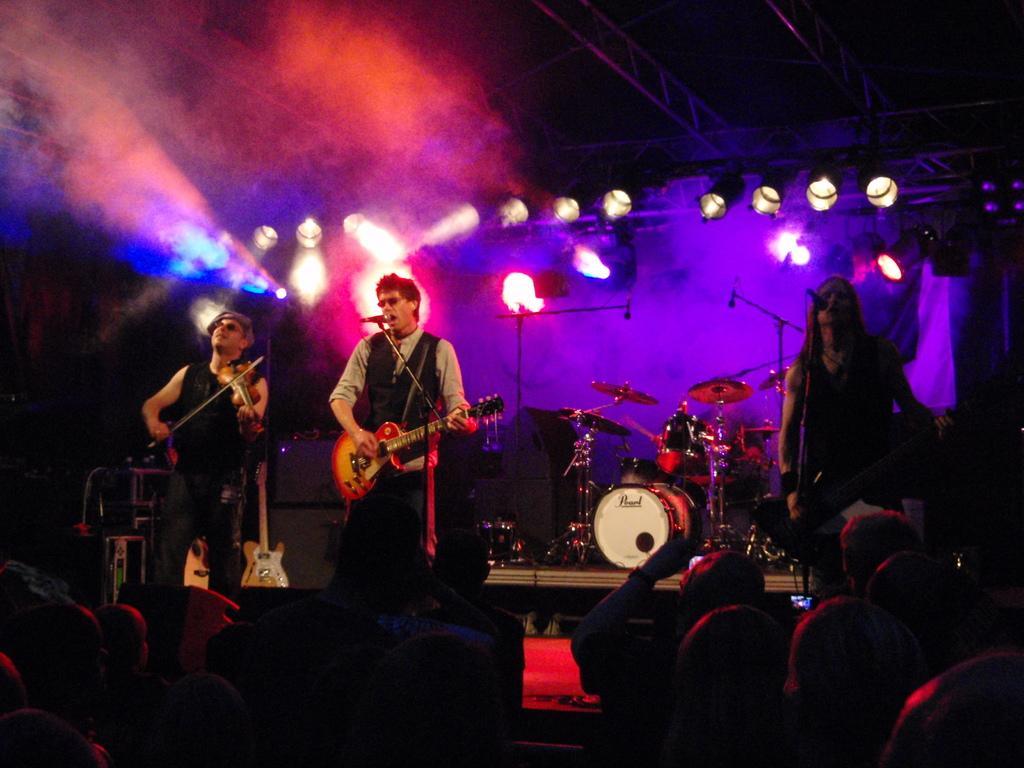Describe this image in one or two sentences. In the image there are three people who are standing and playing their musical instruments. In middle there is a man playing a guitar and opened his mouth in front of a microphone for singing and there are group of people as audience. In background we can see few musical instruments on top there is a roof with some lights. 